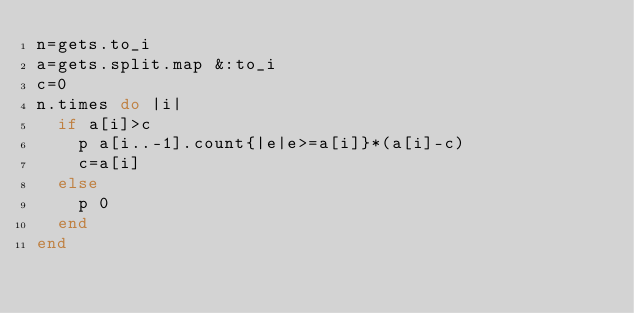<code> <loc_0><loc_0><loc_500><loc_500><_Ruby_>n=gets.to_i
a=gets.split.map &:to_i
c=0
n.times do |i|
  if a[i]>c
    p a[i..-1].count{|e|e>=a[i]}*(a[i]-c)
    c=a[i]
  else
    p 0
  end
end</code> 